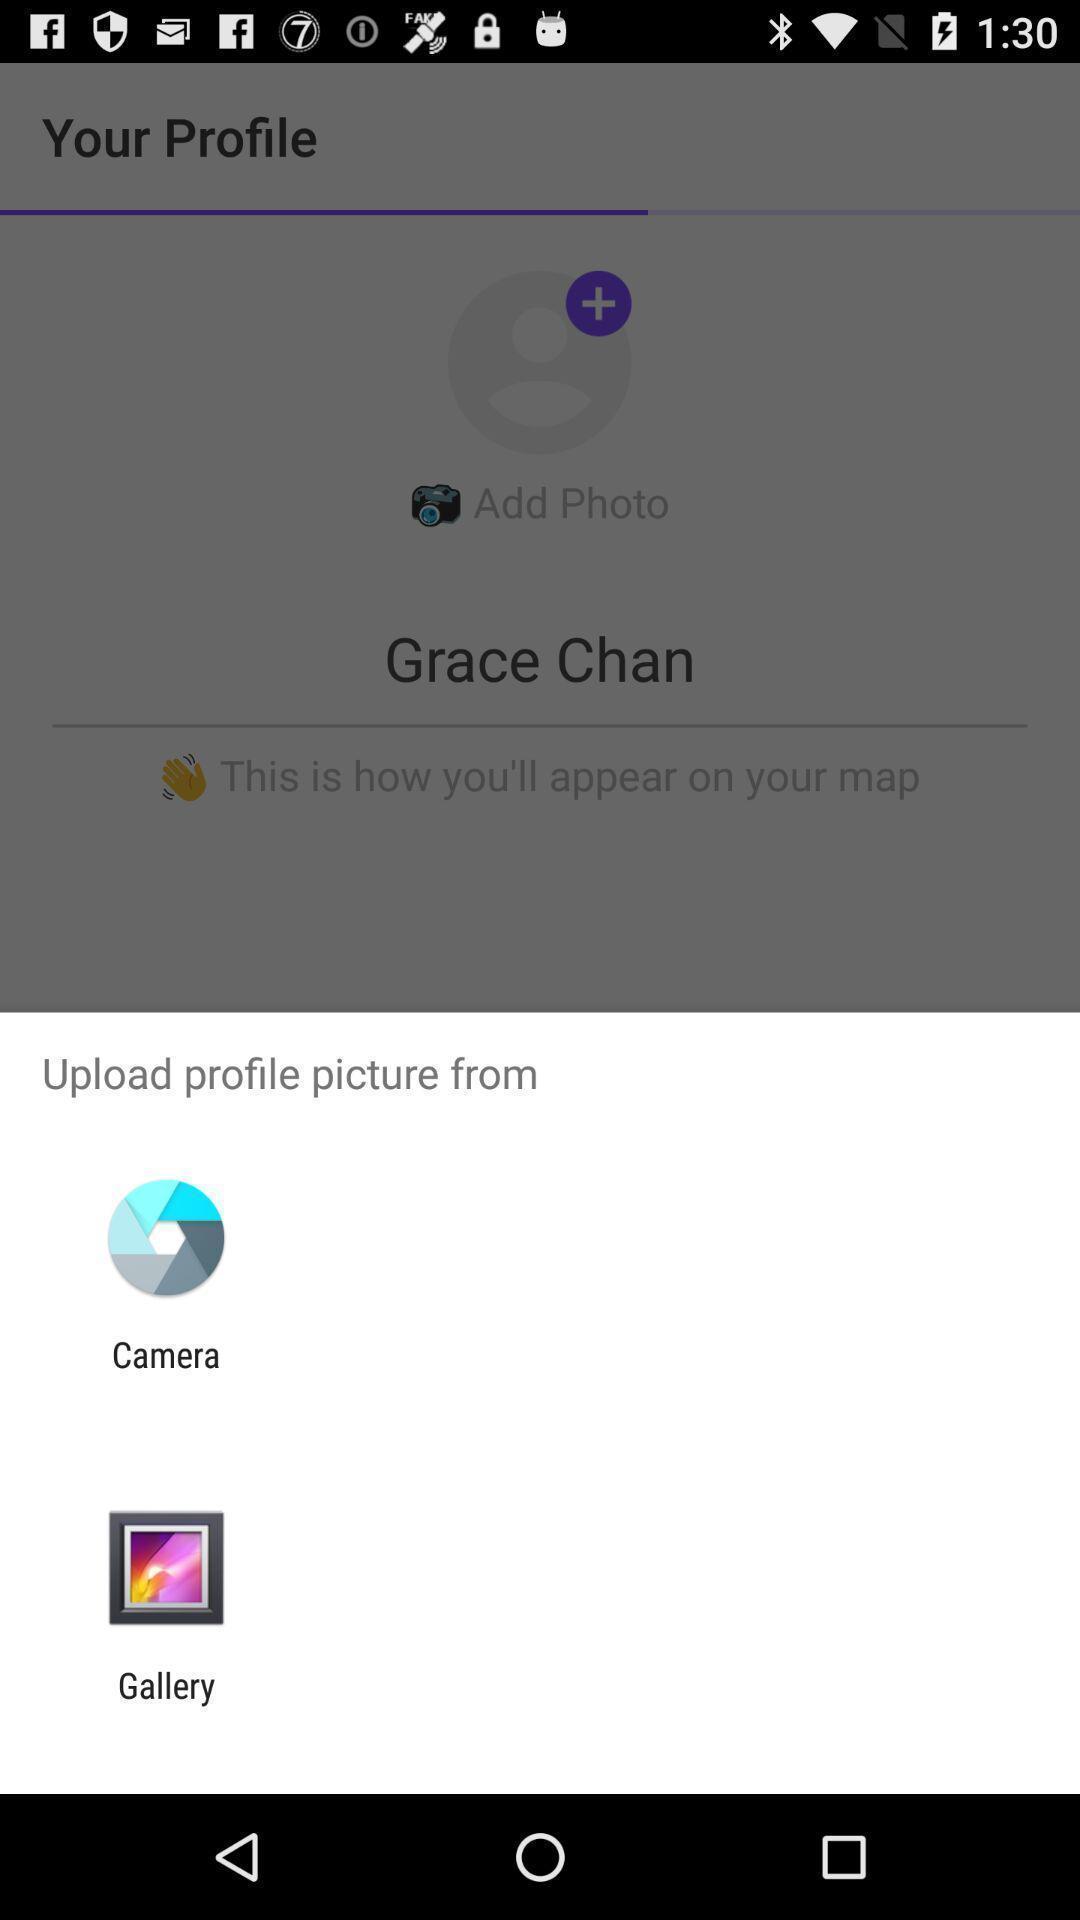Provide a description of this screenshot. Pop-up asking to upload picture using any of the application. 